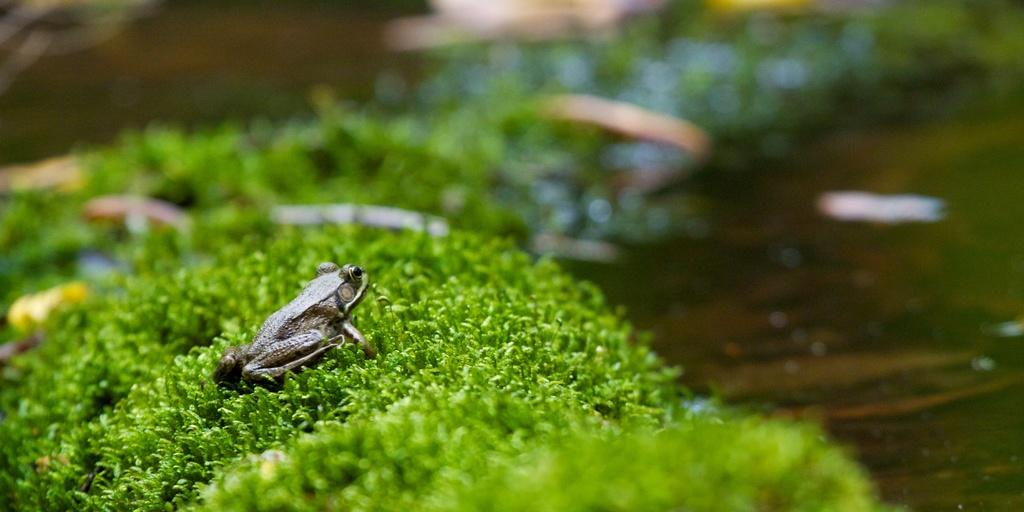What animal is present in the image? There is a frog in the image. What is the frog sitting on? The frog is on green grass. Can you describe the background of the image? The background of the image is blurry. How many cents can be seen on the frog's mouth in the image? There are no cents present in the image, and the frog does not have a mouth. 